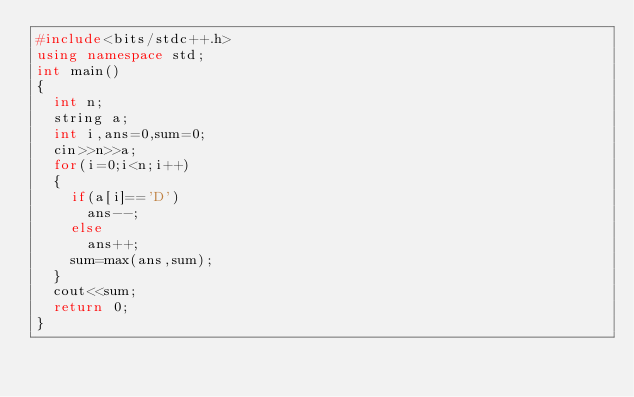Convert code to text. <code><loc_0><loc_0><loc_500><loc_500><_C++_>#include<bits/stdc++.h>
using namespace std;
int main()
{
  int n;	
  string a;
  int i,ans=0,sum=0;
  cin>>n>>a;	
  for(i=0;i<n;i++)
  {
    if(a[i]=='D')
	  ans--;
    else
      ans++;
    sum=max(ans,sum);  
  }
  cout<<sum;
  return 0;
}</code> 